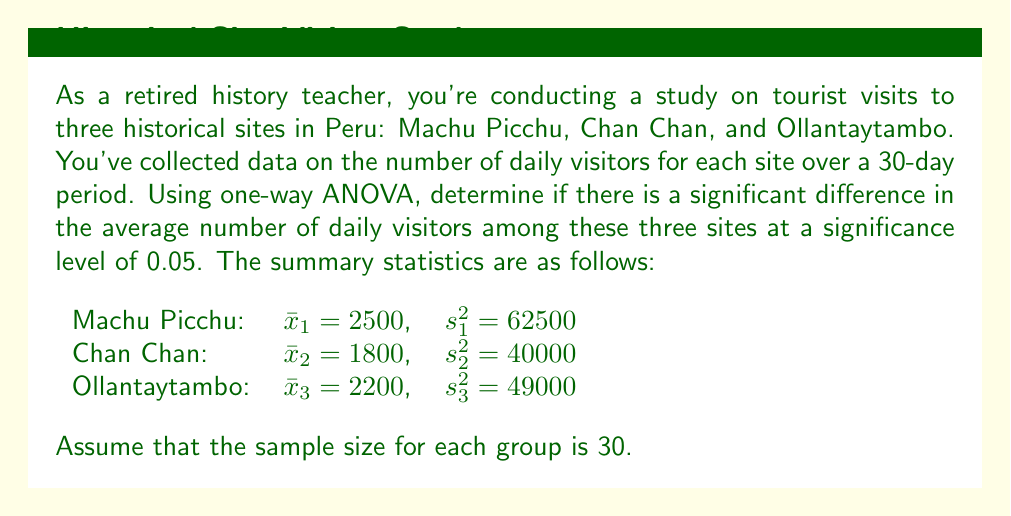Could you help me with this problem? To solve this problem using one-way ANOVA, we need to follow these steps:

1. Calculate the sum of squares between groups (SSB)
2. Calculate the sum of squares within groups (SSW)
3. Calculate the total sum of squares (SST)
4. Compute the degrees of freedom
5. Calculate the mean squares
6. Compute the F-statistic
7. Determine the critical F-value
8. Compare the F-statistic to the critical F-value

Step 1: Calculate SSB
$$SSB = \sum_{i=1}^k n_i(\bar{x}_i - \bar{x})^2$$
where $k$ is the number of groups, $n_i$ is the sample size of each group, $\bar{x}_i$ is the mean of each group, and $\bar{x}$ is the grand mean.

Grand mean: $\bar{x} = \frac{2500 + 1800 + 2200}{3} = 2166.67$

$$SSB = 30(2500 - 2166.67)^2 + 30(1800 - 2166.67)^2 + 30(2200 - 2166.67)^2 = 10,500,000$$

Step 2: Calculate SSW
$$SSW = \sum_{i=1}^k (n_i - 1)s_i^2$$

$$SSW = 29(62500) + 29(40000) + 29(49000) = 4,393,500$$

Step 3: Calculate SST
$$SST = SSB + SSW = 10,500,000 + 4,393,500 = 14,893,500$$

Step 4: Compute degrees of freedom
df between groups = $k - 1 = 3 - 1 = 2$
df within groups = $N - k = 90 - 3 = 87$
df total = $N - 1 = 90 - 1 = 89$

Step 5: Calculate mean squares
$$MSB = \frac{SSB}{df_{between}} = \frac{10,500,000}{2} = 5,250,000$$
$$MSW = \frac{SSW}{df_{within}} = \frac{4,393,500}{87} = 50,500$$

Step 6: Compute F-statistic
$$F = \frac{MSB}{MSW} = \frac{5,250,000}{50,500} = 103.96$$

Step 7: Determine critical F-value
For $\alpha = 0.05$, $df_{between} = 2$, and $df_{within} = 87$, the critical F-value is approximately 3.10.

Step 8: Compare F-statistic to critical F-value
Since $103.96 > 3.10$, we reject the null hypothesis.
Answer: The F-statistic (103.96) is greater than the critical F-value (3.10), so we reject the null hypothesis at the 0.05 significance level. There is strong evidence of a significant difference in the average number of daily visitors among Machu Picchu, Chan Chan, and Ollantaytambo. 